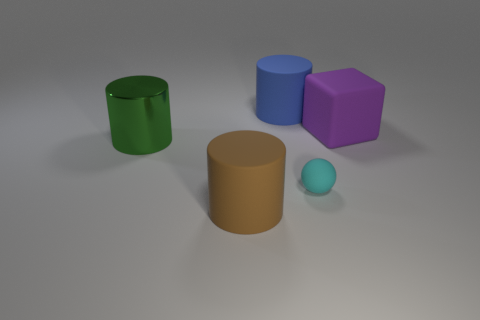How big is the matte object that is both in front of the large purple matte thing and to the left of the cyan rubber object?
Offer a terse response. Large. Are there fewer small matte balls behind the green metal thing than blue cylinders?
Ensure brevity in your answer.  Yes. What is the shape of the other small thing that is made of the same material as the brown thing?
Provide a succinct answer. Sphere. There is a big rubber thing that is to the left of the blue thing; is it the same shape as the big thing behind the large block?
Provide a succinct answer. Yes. Is the number of cyan rubber balls that are behind the small rubber thing less than the number of purple cubes that are on the left side of the brown matte cylinder?
Provide a succinct answer. No. How many purple blocks are the same size as the green metallic thing?
Give a very brief answer. 1. Are the object to the right of the small cyan thing and the small thing made of the same material?
Make the answer very short. Yes. Are there any rubber cylinders?
Keep it short and to the point. Yes. There is a cyan thing that is made of the same material as the brown cylinder; what size is it?
Offer a terse response. Small. Is there a matte cylinder that has the same color as the large metal cylinder?
Your answer should be very brief. No. 